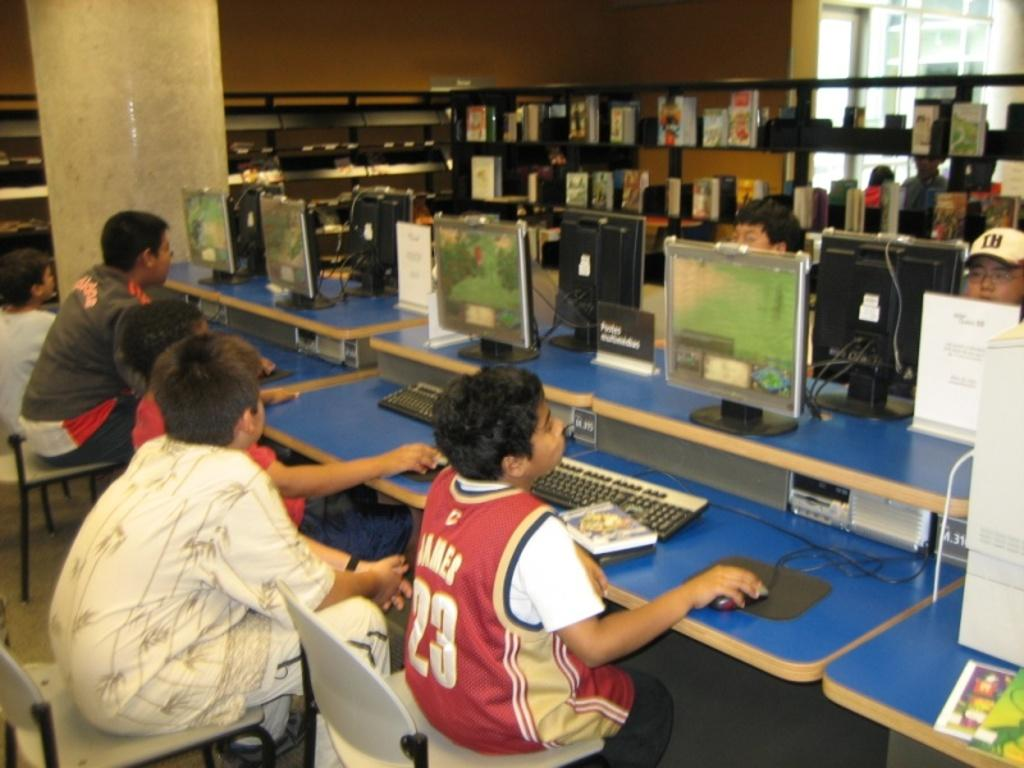Provide a one-sentence caption for the provided image. A boy wearing a James jersey sits with other children playing computer games. 